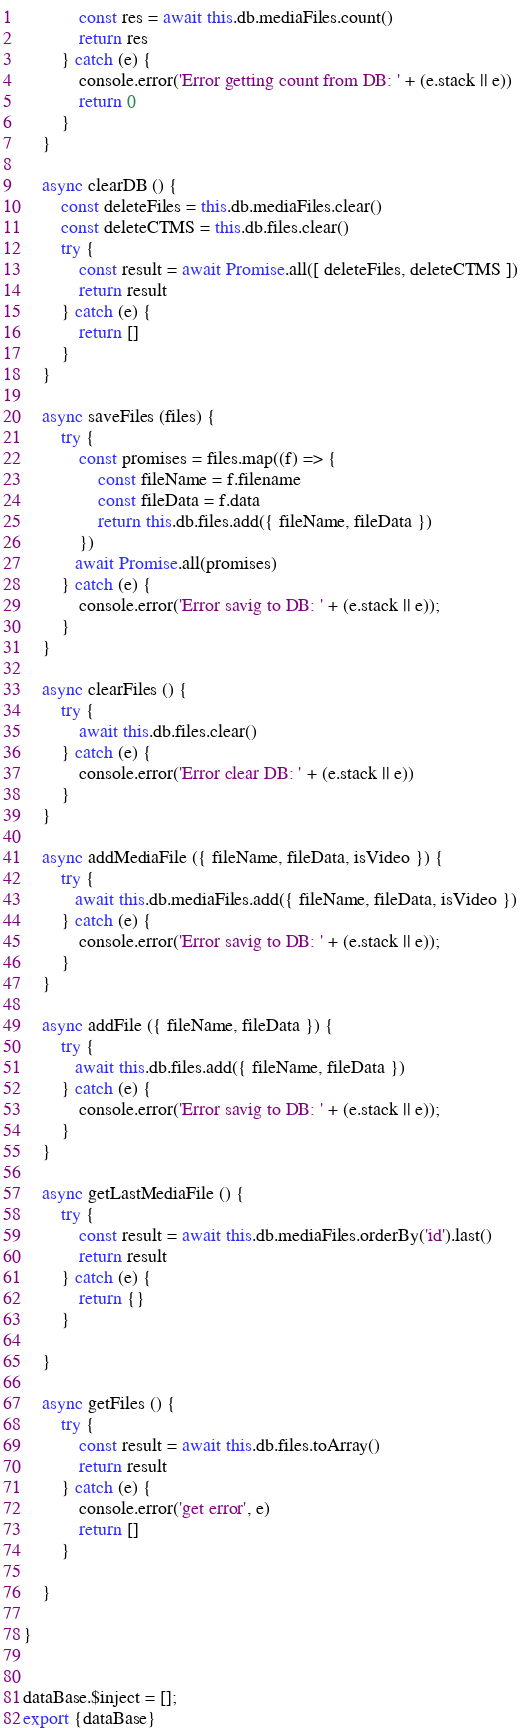<code> <loc_0><loc_0><loc_500><loc_500><_JavaScript_>            const res = await this.db.mediaFiles.count()
            return res
        } catch (e) {
            console.error('Error getting count from DB: ' + (e.stack || e))
            return 0
        }
    }

    async clearDB () {
        const deleteFiles = this.db.mediaFiles.clear()
        const deleteCTMS = this.db.files.clear()
        try {
            const result = await Promise.all([ deleteFiles, deleteCTMS ])
            return result
        } catch (e) {
            return []
        }   
    }

    async saveFiles (files) {
        try {
            const promises = files.map((f) => {
                const fileName = f.filename
                const fileData = f.data
                return this.db.files.add({ fileName, fileData })
            })
           await Promise.all(promises)
        } catch (e) {
            console.error('Error savig to DB: ' + (e.stack || e));
        }
    }

    async clearFiles () {
        try {
            await this.db.files.clear()
        } catch (e) {
            console.error('Error clear DB: ' + (e.stack || e))
        }
    }

    async addMediaFile ({ fileName, fileData, isVideo }) {
        try {
           await this.db.mediaFiles.add({ fileName, fileData, isVideo })
        } catch (e) {
            console.error('Error savig to DB: ' + (e.stack || e));
        }
    }

    async addFile ({ fileName, fileData }) {
        try {
           await this.db.files.add({ fileName, fileData })
        } catch (e) {
            console.error('Error savig to DB: ' + (e.stack || e));
        }
    }

    async getLastMediaFile () {
        try {
            const result = await this.db.mediaFiles.orderBy('id').last()
            return result      
        } catch (e) {
            return {}
        }
        
    }

    async getFiles () {
        try {
            const result = await this.db.files.toArray()
            return result
        } catch (e) {
            console.error('get error', e)
            return []
        }
        
    }

}


dataBase.$inject = [];
export {dataBase}</code> 